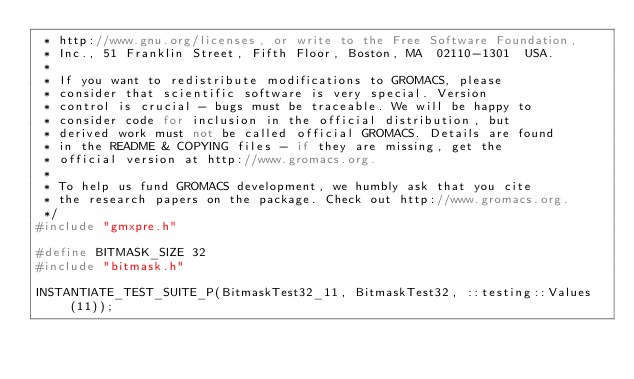Convert code to text. <code><loc_0><loc_0><loc_500><loc_500><_C++_> * http://www.gnu.org/licenses, or write to the Free Software Foundation,
 * Inc., 51 Franklin Street, Fifth Floor, Boston, MA  02110-1301  USA.
 *
 * If you want to redistribute modifications to GROMACS, please
 * consider that scientific software is very special. Version
 * control is crucial - bugs must be traceable. We will be happy to
 * consider code for inclusion in the official distribution, but
 * derived work must not be called official GROMACS. Details are found
 * in the README & COPYING files - if they are missing, get the
 * official version at http://www.gromacs.org.
 *
 * To help us fund GROMACS development, we humbly ask that you cite
 * the research papers on the package. Check out http://www.gromacs.org.
 */
#include "gmxpre.h"

#define BITMASK_SIZE 32
#include "bitmask.h"

INSTANTIATE_TEST_SUITE_P(BitmaskTest32_11, BitmaskTest32, ::testing::Values(11));
</code> 